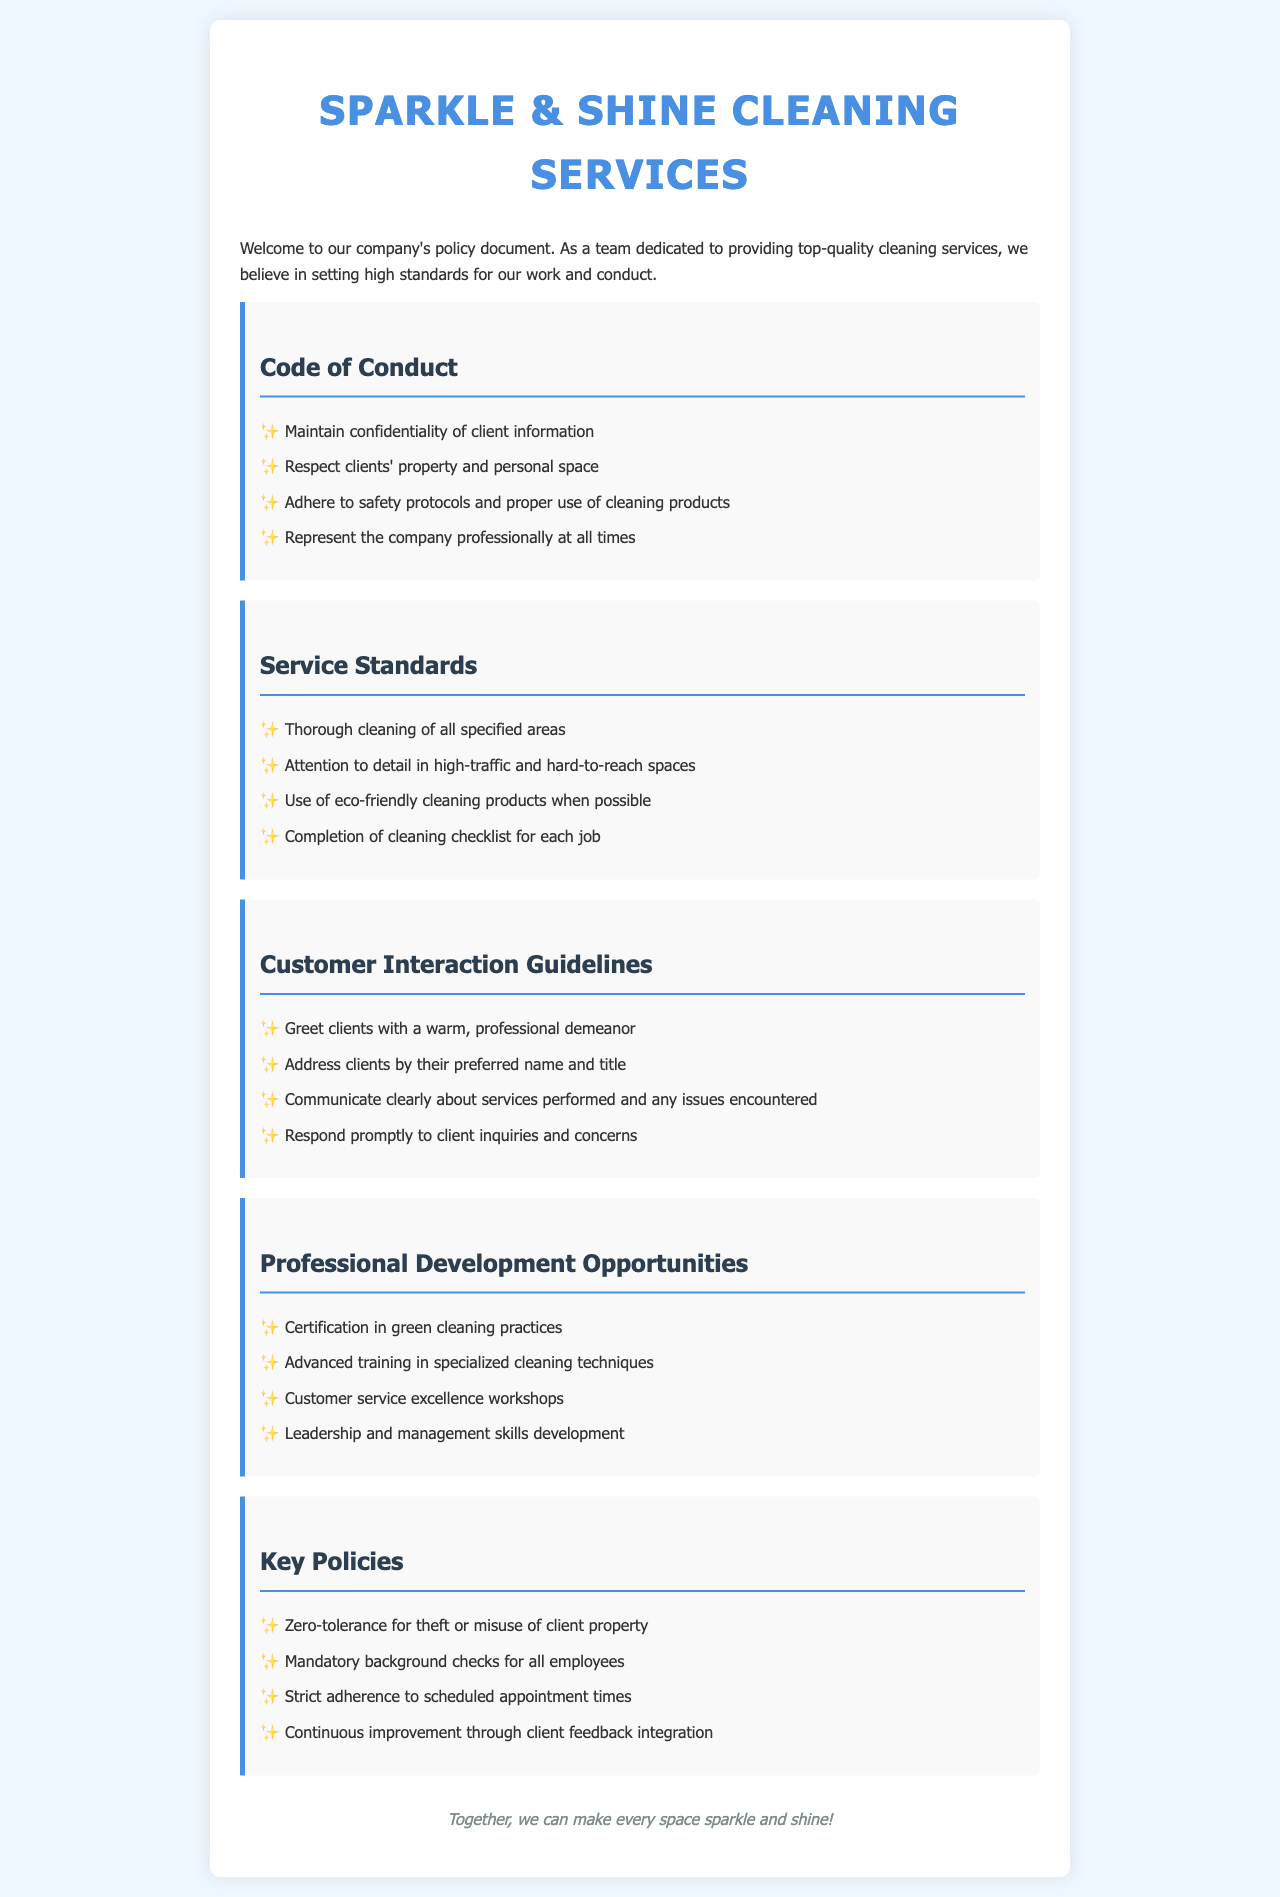what is the first item listed in the Code of Conduct? The first item in the Code of Conduct outlines the need to maintain confidentiality of client information.
Answer: Maintain confidentiality of client information how many key policies are mentioned in the document? The document lists a total of four key policies that are crucial for conduct within the service.
Answer: 4 which cleaning products are preferred according to the Service Standards? The Service Standards emphasize the use of eco-friendly cleaning products whenever possible.
Answer: Eco-friendly cleaning products what is one of the professional development opportunities offered? One of the professional development opportunities includes certification in green cleaning practices, which enhances service quality.
Answer: Certification in green cleaning practices what should employees do when they interact with clients? Employees are required to greet clients with a warm, professional demeanor during interactions.
Answer: Greet clients with a warm, professional demeanor which document section includes guidelines for responding to client inquiries? The Customer Interaction Guidelines section covers how to respond promptly to client inquiries and concerns.
Answer: Customer Interaction Guidelines what action is taken for employee background checks? The document specifies that there are mandatory background checks for all employees to ensure safety and professionalism.
Answer: Mandatory background checks what is the primary goal stated within the policy document? The overarching goal expressed in the policy document is to make every space sparkle and shine.
Answer: Make every space sparkle and shine 